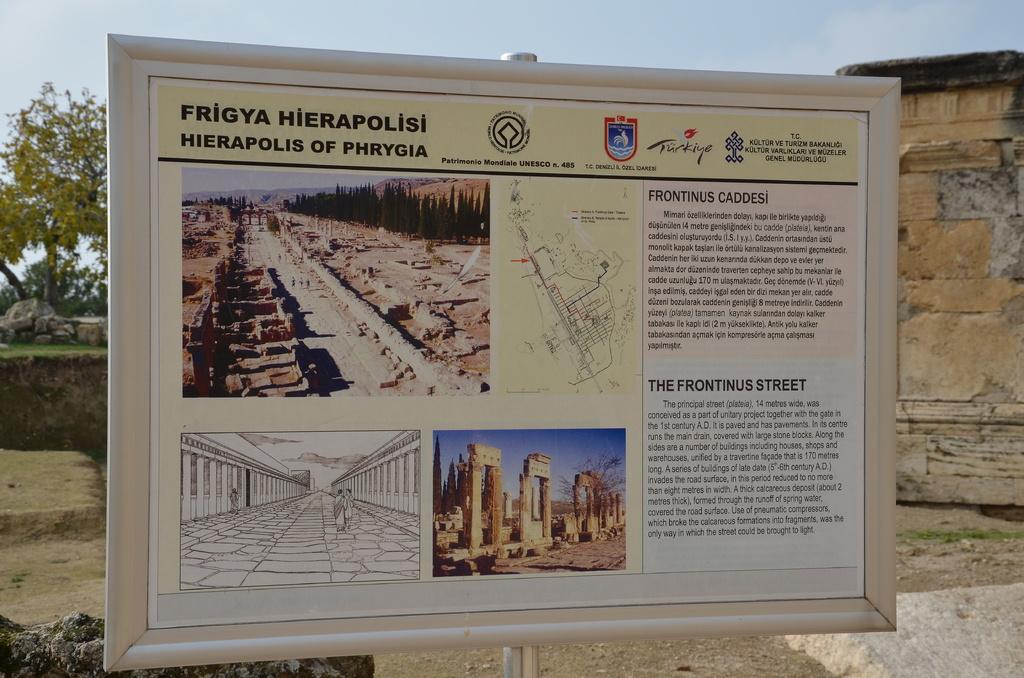What is the name of this structure?
Keep it short and to the point. Frigya hierapolisi. 